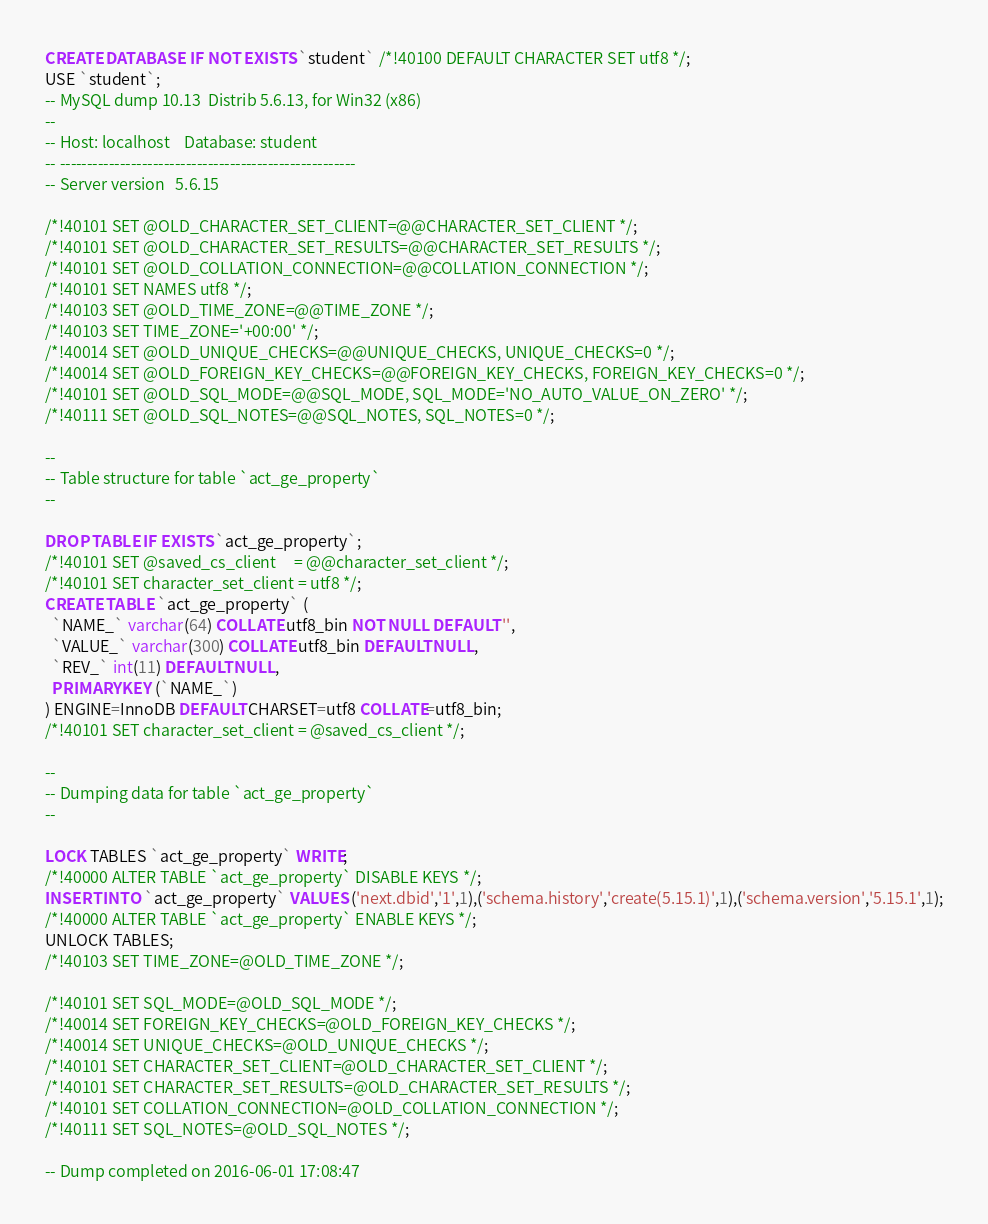Convert code to text. <code><loc_0><loc_0><loc_500><loc_500><_SQL_>CREATE DATABASE  IF NOT EXISTS `student` /*!40100 DEFAULT CHARACTER SET utf8 */;
USE `student`;
-- MySQL dump 10.13  Distrib 5.6.13, for Win32 (x86)
--
-- Host: localhost    Database: student
-- ------------------------------------------------------
-- Server version	5.6.15

/*!40101 SET @OLD_CHARACTER_SET_CLIENT=@@CHARACTER_SET_CLIENT */;
/*!40101 SET @OLD_CHARACTER_SET_RESULTS=@@CHARACTER_SET_RESULTS */;
/*!40101 SET @OLD_COLLATION_CONNECTION=@@COLLATION_CONNECTION */;
/*!40101 SET NAMES utf8 */;
/*!40103 SET @OLD_TIME_ZONE=@@TIME_ZONE */;
/*!40103 SET TIME_ZONE='+00:00' */;
/*!40014 SET @OLD_UNIQUE_CHECKS=@@UNIQUE_CHECKS, UNIQUE_CHECKS=0 */;
/*!40014 SET @OLD_FOREIGN_KEY_CHECKS=@@FOREIGN_KEY_CHECKS, FOREIGN_KEY_CHECKS=0 */;
/*!40101 SET @OLD_SQL_MODE=@@SQL_MODE, SQL_MODE='NO_AUTO_VALUE_ON_ZERO' */;
/*!40111 SET @OLD_SQL_NOTES=@@SQL_NOTES, SQL_NOTES=0 */;

--
-- Table structure for table `act_ge_property`
--

DROP TABLE IF EXISTS `act_ge_property`;
/*!40101 SET @saved_cs_client     = @@character_set_client */;
/*!40101 SET character_set_client = utf8 */;
CREATE TABLE `act_ge_property` (
  `NAME_` varchar(64) COLLATE utf8_bin NOT NULL DEFAULT '',
  `VALUE_` varchar(300) COLLATE utf8_bin DEFAULT NULL,
  `REV_` int(11) DEFAULT NULL,
  PRIMARY KEY (`NAME_`)
) ENGINE=InnoDB DEFAULT CHARSET=utf8 COLLATE=utf8_bin;
/*!40101 SET character_set_client = @saved_cs_client */;

--
-- Dumping data for table `act_ge_property`
--

LOCK TABLES `act_ge_property` WRITE;
/*!40000 ALTER TABLE `act_ge_property` DISABLE KEYS */;
INSERT INTO `act_ge_property` VALUES ('next.dbid','1',1),('schema.history','create(5.15.1)',1),('schema.version','5.15.1',1);
/*!40000 ALTER TABLE `act_ge_property` ENABLE KEYS */;
UNLOCK TABLES;
/*!40103 SET TIME_ZONE=@OLD_TIME_ZONE */;

/*!40101 SET SQL_MODE=@OLD_SQL_MODE */;
/*!40014 SET FOREIGN_KEY_CHECKS=@OLD_FOREIGN_KEY_CHECKS */;
/*!40014 SET UNIQUE_CHECKS=@OLD_UNIQUE_CHECKS */;
/*!40101 SET CHARACTER_SET_CLIENT=@OLD_CHARACTER_SET_CLIENT */;
/*!40101 SET CHARACTER_SET_RESULTS=@OLD_CHARACTER_SET_RESULTS */;
/*!40101 SET COLLATION_CONNECTION=@OLD_COLLATION_CONNECTION */;
/*!40111 SET SQL_NOTES=@OLD_SQL_NOTES */;

-- Dump completed on 2016-06-01 17:08:47
</code> 